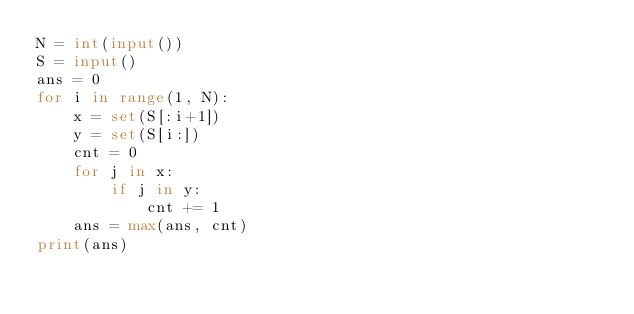Convert code to text. <code><loc_0><loc_0><loc_500><loc_500><_Python_>N = int(input())
S = input()
ans = 0
for i in range(1, N):
    x = set(S[:i+1])
    y = set(S[i:])
    cnt = 0
    for j in x:
        if j in y:
            cnt += 1
    ans = max(ans, cnt)
print(ans)
</code> 